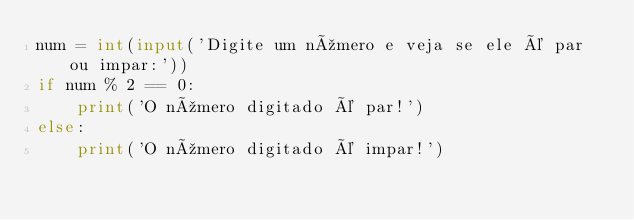Convert code to text. <code><loc_0><loc_0><loc_500><loc_500><_Python_>num = int(input('Digite um número e veja se ele é par ou impar:'))
if num % 2 == 0:
    print('O número digitado é par!')
else:
    print('O número digitado é impar!')


</code> 